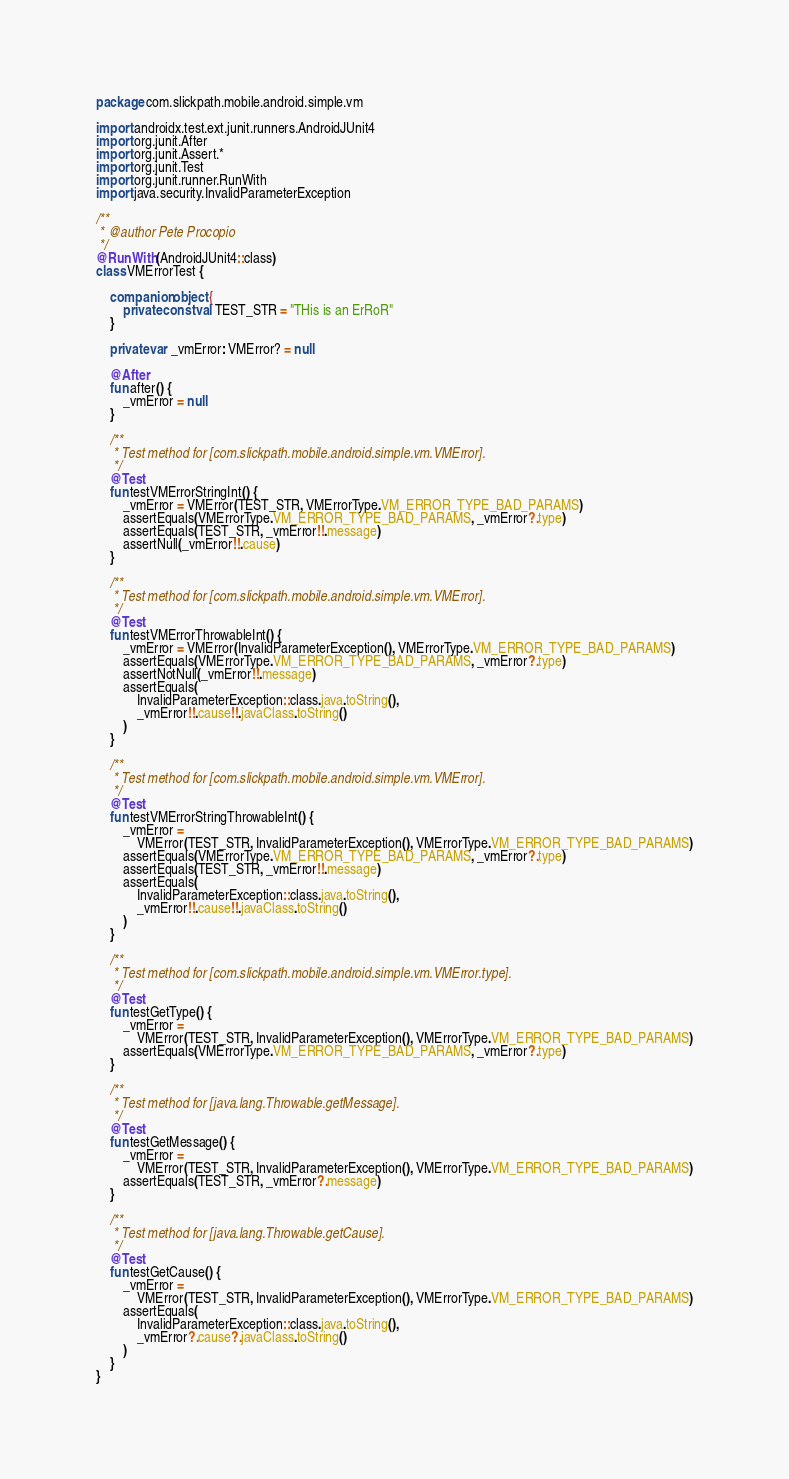<code> <loc_0><loc_0><loc_500><loc_500><_Kotlin_>package com.slickpath.mobile.android.simple.vm

import androidx.test.ext.junit.runners.AndroidJUnit4
import org.junit.After
import org.junit.Assert.*
import org.junit.Test
import org.junit.runner.RunWith
import java.security.InvalidParameterException

/**
 * @author Pete Procopio
 */
@RunWith(AndroidJUnit4::class)
class VMErrorTest {

    companion object {
        private const val TEST_STR = "THis is an ErRoR"
    }

    private var _vmError: VMError? = null

    @After
    fun after() {
        _vmError = null
    }

    /**
     * Test method for [com.slickpath.mobile.android.simple.vm.VMError].
     */
    @Test
    fun testVMErrorStringInt() {
        _vmError = VMError(TEST_STR, VMErrorType.VM_ERROR_TYPE_BAD_PARAMS)
        assertEquals(VMErrorType.VM_ERROR_TYPE_BAD_PARAMS, _vmError?.type)
        assertEquals(TEST_STR, _vmError!!.message)
        assertNull(_vmError!!.cause)
    }

    /**
     * Test method for [com.slickpath.mobile.android.simple.vm.VMError].
     */
    @Test
    fun testVMErrorThrowableInt() {
        _vmError = VMError(InvalidParameterException(), VMErrorType.VM_ERROR_TYPE_BAD_PARAMS)
        assertEquals(VMErrorType.VM_ERROR_TYPE_BAD_PARAMS, _vmError?.type)
        assertNotNull(_vmError!!.message)
        assertEquals(
            InvalidParameterException::class.java.toString(),
            _vmError!!.cause!!.javaClass.toString()
        )
    }

    /**
     * Test method for [com.slickpath.mobile.android.simple.vm.VMError].
     */
    @Test
    fun testVMErrorStringThrowableInt() {
        _vmError =
            VMError(TEST_STR, InvalidParameterException(), VMErrorType.VM_ERROR_TYPE_BAD_PARAMS)
        assertEquals(VMErrorType.VM_ERROR_TYPE_BAD_PARAMS, _vmError?.type)
        assertEquals(TEST_STR, _vmError!!.message)
        assertEquals(
            InvalidParameterException::class.java.toString(),
            _vmError!!.cause!!.javaClass.toString()
        )
    }

    /**
     * Test method for [com.slickpath.mobile.android.simple.vm.VMError.type].
     */
    @Test
    fun testGetType() {
        _vmError =
            VMError(TEST_STR, InvalidParameterException(), VMErrorType.VM_ERROR_TYPE_BAD_PARAMS)
        assertEquals(VMErrorType.VM_ERROR_TYPE_BAD_PARAMS, _vmError?.type)
    }

    /**
     * Test method for [java.lang.Throwable.getMessage].
     */
    @Test
    fun testGetMessage() {
        _vmError =
            VMError(TEST_STR, InvalidParameterException(), VMErrorType.VM_ERROR_TYPE_BAD_PARAMS)
        assertEquals(TEST_STR, _vmError?.message)
    }

    /**
     * Test method for [java.lang.Throwable.getCause].
     */
    @Test
    fun testGetCause() {
        _vmError =
            VMError(TEST_STR, InvalidParameterException(), VMErrorType.VM_ERROR_TYPE_BAD_PARAMS)
        assertEquals(
            InvalidParameterException::class.java.toString(),
            _vmError?.cause?.javaClass.toString()
        )
    }
}</code> 